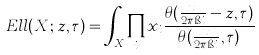<formula> <loc_0><loc_0><loc_500><loc_500>E l l ( X ; z , \tau ) = \int _ { X } \prod _ { i } x _ { i } \frac { \theta ( \frac { x _ { i } } { 2 \pi \i i } - z , \tau ) } { \theta ( \frac { x _ { i } } { 2 \pi \i i } , \tau ) }</formula> 